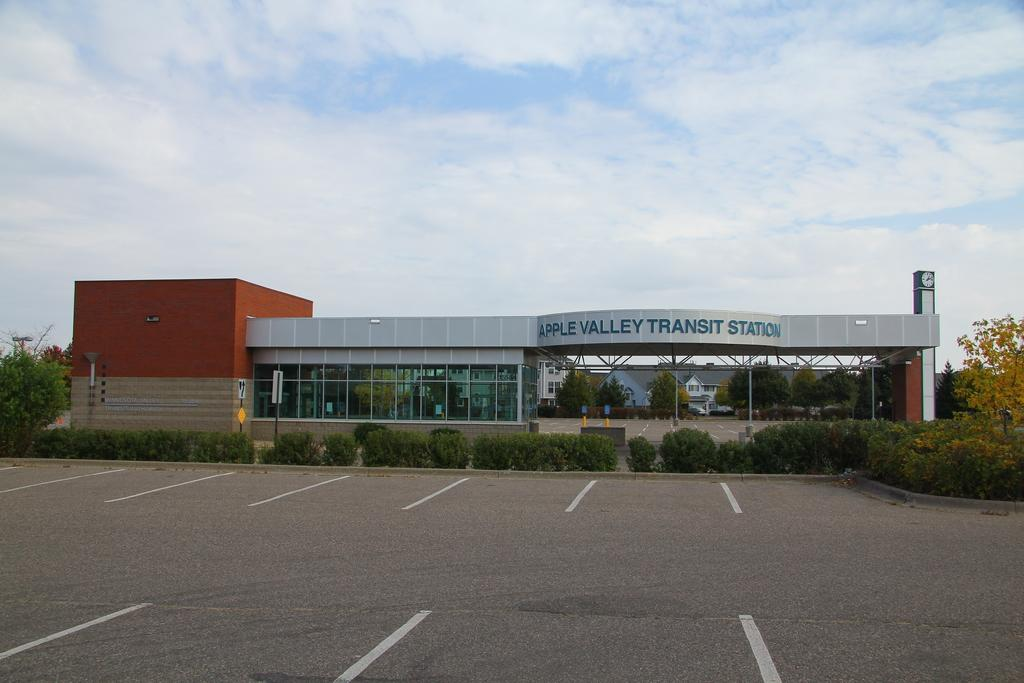<image>
Create a compact narrative representing the image presented. Apple Valley Transit Station is displayed as the name of this building. 